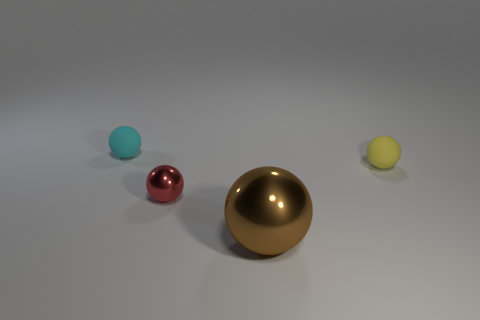How would you describe the texture and material of the large ball in the foreground? The large ball in the foreground has a polished, reflective texture suggesting it's made of metal, perhaps due to the way it reflects light and its surroundings with a high degree of specular highlight. 